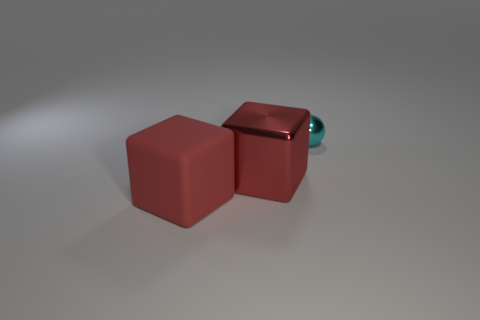Can you describe the lighting and the setting of the image? The setting is a minimalistic scene with neutral lighting, which casts soft shadows on a light grey surface, thereby giving the objects a three-dimensional effect and emphasizing their shapes and colors. 